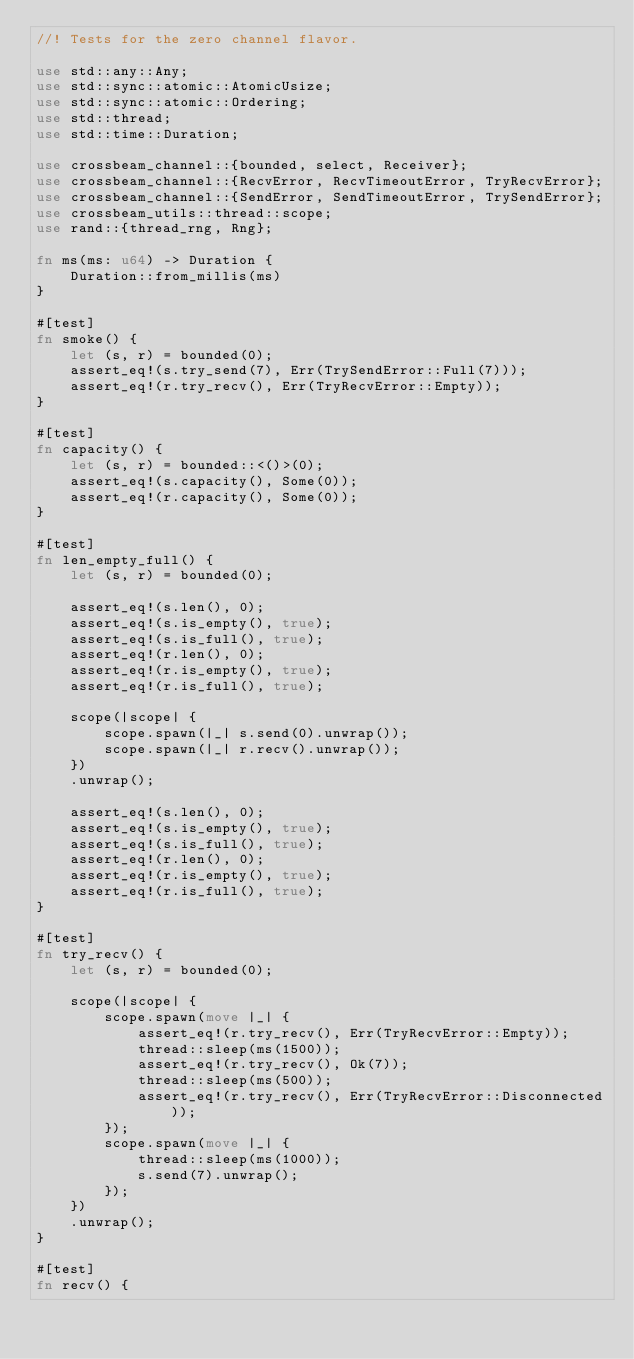<code> <loc_0><loc_0><loc_500><loc_500><_Rust_>//! Tests for the zero channel flavor.

use std::any::Any;
use std::sync::atomic::AtomicUsize;
use std::sync::atomic::Ordering;
use std::thread;
use std::time::Duration;

use crossbeam_channel::{bounded, select, Receiver};
use crossbeam_channel::{RecvError, RecvTimeoutError, TryRecvError};
use crossbeam_channel::{SendError, SendTimeoutError, TrySendError};
use crossbeam_utils::thread::scope;
use rand::{thread_rng, Rng};

fn ms(ms: u64) -> Duration {
    Duration::from_millis(ms)
}

#[test]
fn smoke() {
    let (s, r) = bounded(0);
    assert_eq!(s.try_send(7), Err(TrySendError::Full(7)));
    assert_eq!(r.try_recv(), Err(TryRecvError::Empty));
}

#[test]
fn capacity() {
    let (s, r) = bounded::<()>(0);
    assert_eq!(s.capacity(), Some(0));
    assert_eq!(r.capacity(), Some(0));
}

#[test]
fn len_empty_full() {
    let (s, r) = bounded(0);

    assert_eq!(s.len(), 0);
    assert_eq!(s.is_empty(), true);
    assert_eq!(s.is_full(), true);
    assert_eq!(r.len(), 0);
    assert_eq!(r.is_empty(), true);
    assert_eq!(r.is_full(), true);

    scope(|scope| {
        scope.spawn(|_| s.send(0).unwrap());
        scope.spawn(|_| r.recv().unwrap());
    })
    .unwrap();

    assert_eq!(s.len(), 0);
    assert_eq!(s.is_empty(), true);
    assert_eq!(s.is_full(), true);
    assert_eq!(r.len(), 0);
    assert_eq!(r.is_empty(), true);
    assert_eq!(r.is_full(), true);
}

#[test]
fn try_recv() {
    let (s, r) = bounded(0);

    scope(|scope| {
        scope.spawn(move |_| {
            assert_eq!(r.try_recv(), Err(TryRecvError::Empty));
            thread::sleep(ms(1500));
            assert_eq!(r.try_recv(), Ok(7));
            thread::sleep(ms(500));
            assert_eq!(r.try_recv(), Err(TryRecvError::Disconnected));
        });
        scope.spawn(move |_| {
            thread::sleep(ms(1000));
            s.send(7).unwrap();
        });
    })
    .unwrap();
}

#[test]
fn recv() {</code> 